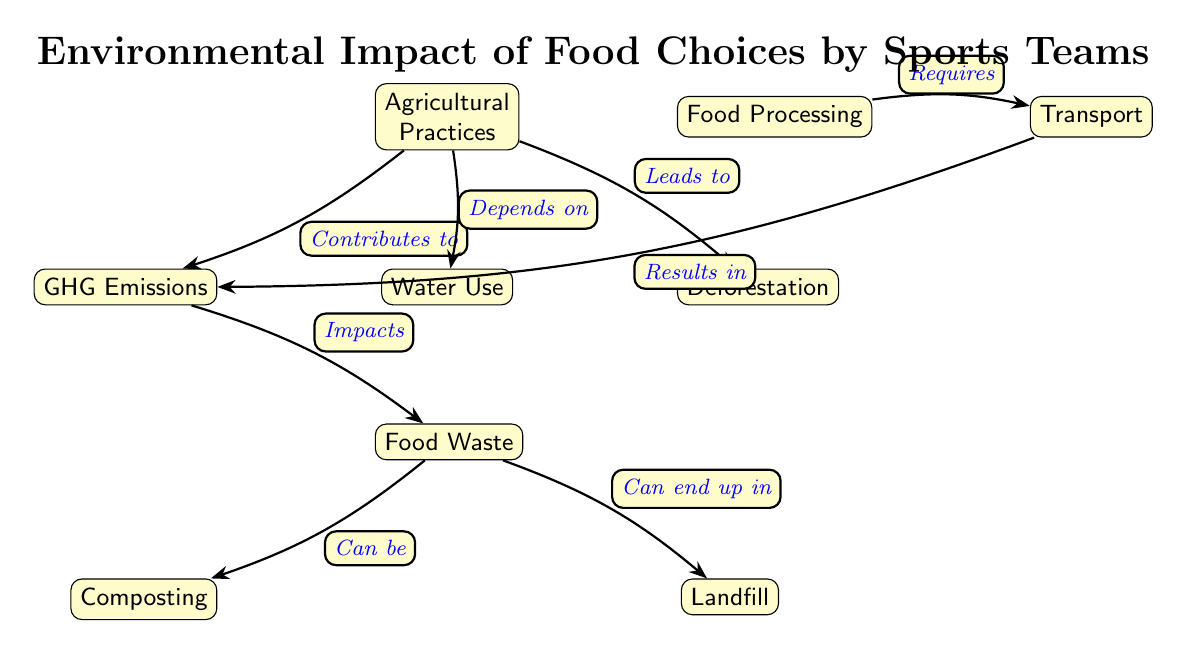What is the first node in the diagram? The first node in the diagram is where the flow begins, shown at the top. This node is labeled "Agricultural Practices."
Answer: Agricultural Practices How many nodes are there in total? To find the total number of nodes, I can count each distinct concept represented in the diagram. There are nine nodes present.
Answer: 9 What does "Agricultural Practices" lead to? "Agricultural Practices" leads to several other nodes, including "Deforestation," "GHG Emissions," and "Water Use." The edge labeled "Leads to" specifically indicates that it connects to "Deforestation."
Answer: Deforestation Which node is directly influenced by "GHG Emissions"? The node that is directly influenced by "GHG Emissions" is "Food Waste," connected through the edge stating "Impacts."
Answer: Food Waste What is the relationship between "Food Waste" and "Composting"? The relationship between "Food Waste" and "Composting" is indicated by the edge that shows that food waste "Can be" composted, demonstrating a potential method for its disposal.
Answer: Can be How does "Transport" relate to "Food Processing"? "Transport" is shown to be a consequence of "Food Processing," illustrated by the edge labeled "Requires," which connects the two nodes in a sequential manner.
Answer: Requires From which node does "GHG Emissions" result? "GHG Emissions" results from the process represented by "Transport," as indicated by the edge labeled "Results in." This shows a sequence where more transport leads to more emissions.
Answer: Transport Where does "Food Waste" end up besides composting? Besides composting, "Food Waste" can end up in "Landfill," as shown by the edge that states "Can end up in."
Answer: Landfill What environmental issue does "Deforestation" lead to in the diagram? "Deforestation" leads to "GHG Emissions," indicating that as forests are cleared, greenhouse gases are released into the atmosphere. This is represented by the edge labeled "Leads to."
Answer: GHG Emissions 